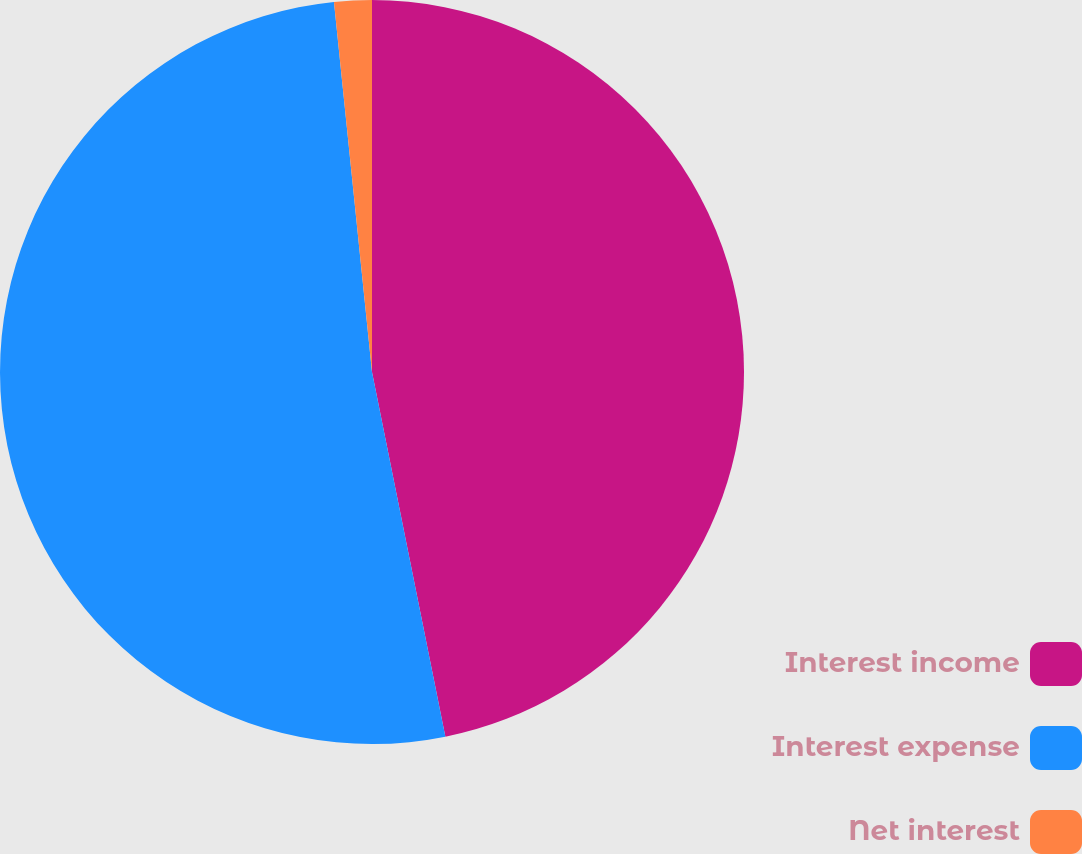<chart> <loc_0><loc_0><loc_500><loc_500><pie_chart><fcel>Interest income<fcel>Interest expense<fcel>Net interest<nl><fcel>46.84%<fcel>51.53%<fcel>1.63%<nl></chart> 